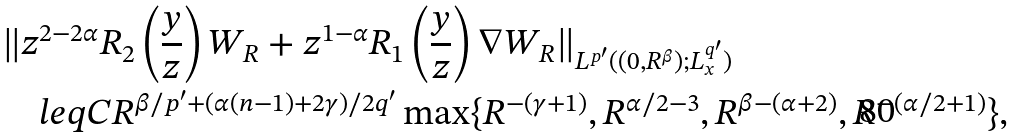Convert formula to latex. <formula><loc_0><loc_0><loc_500><loc_500>& \| z ^ { 2 - 2 \alpha } R _ { 2 } \left ( \frac { y } { z } \right ) W _ { R } + z ^ { 1 - \alpha } R _ { 1 } \left ( \frac { y } { z } \right ) \nabla W _ { R } \| _ { L ^ { p ^ { \prime } } ( ( 0 , R ^ { \beta } ) ; L ^ { q ^ { \prime } } _ { x } ) } \\ & \quad l e q C R ^ { \beta / p ^ { \prime } + ( \alpha ( n - 1 ) + 2 \gamma ) / 2 q ^ { \prime } } \max \{ R ^ { - ( \gamma + 1 ) } , R ^ { \alpha / 2 - 3 } , R ^ { \beta - ( \alpha + 2 ) } , R ^ { - ( \alpha / 2 + 1 ) } \} ,</formula> 